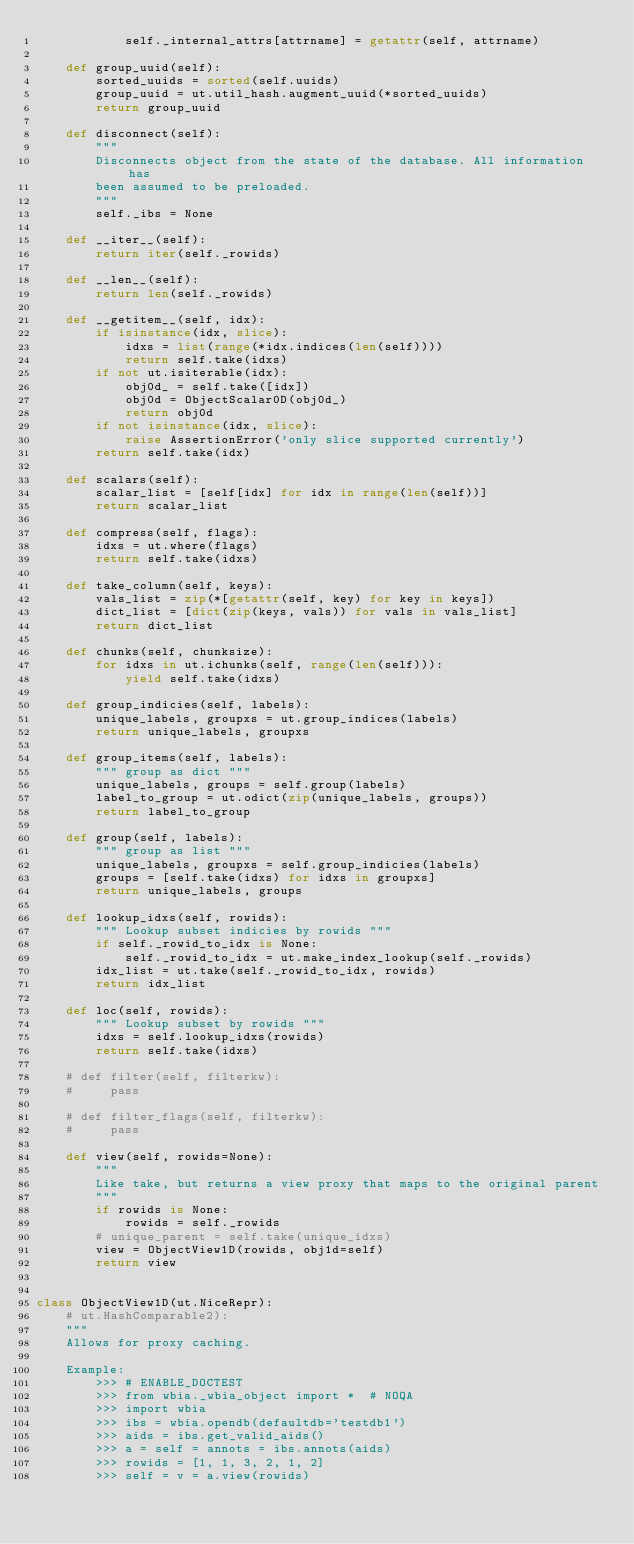Convert code to text. <code><loc_0><loc_0><loc_500><loc_500><_Python_>            self._internal_attrs[attrname] = getattr(self, attrname)

    def group_uuid(self):
        sorted_uuids = sorted(self.uuids)
        group_uuid = ut.util_hash.augment_uuid(*sorted_uuids)
        return group_uuid

    def disconnect(self):
        """
        Disconnects object from the state of the database. All information has
        been assumed to be preloaded.
        """
        self._ibs = None

    def __iter__(self):
        return iter(self._rowids)

    def __len__(self):
        return len(self._rowids)

    def __getitem__(self, idx):
        if isinstance(idx, slice):
            idxs = list(range(*idx.indices(len(self))))
            return self.take(idxs)
        if not ut.isiterable(idx):
            obj0d_ = self.take([idx])
            obj0d = ObjectScalar0D(obj0d_)
            return obj0d
        if not isinstance(idx, slice):
            raise AssertionError('only slice supported currently')
        return self.take(idx)

    def scalars(self):
        scalar_list = [self[idx] for idx in range(len(self))]
        return scalar_list

    def compress(self, flags):
        idxs = ut.where(flags)
        return self.take(idxs)

    def take_column(self, keys):
        vals_list = zip(*[getattr(self, key) for key in keys])
        dict_list = [dict(zip(keys, vals)) for vals in vals_list]
        return dict_list

    def chunks(self, chunksize):
        for idxs in ut.ichunks(self, range(len(self))):
            yield self.take(idxs)

    def group_indicies(self, labels):
        unique_labels, groupxs = ut.group_indices(labels)
        return unique_labels, groupxs

    def group_items(self, labels):
        """ group as dict """
        unique_labels, groups = self.group(labels)
        label_to_group = ut.odict(zip(unique_labels, groups))
        return label_to_group

    def group(self, labels):
        """ group as list """
        unique_labels, groupxs = self.group_indicies(labels)
        groups = [self.take(idxs) for idxs in groupxs]
        return unique_labels, groups

    def lookup_idxs(self, rowids):
        """ Lookup subset indicies by rowids """
        if self._rowid_to_idx is None:
            self._rowid_to_idx = ut.make_index_lookup(self._rowids)
        idx_list = ut.take(self._rowid_to_idx, rowids)
        return idx_list

    def loc(self, rowids):
        """ Lookup subset by rowids """
        idxs = self.lookup_idxs(rowids)
        return self.take(idxs)

    # def filter(self, filterkw):
    #     pass

    # def filter_flags(self, filterkw):
    #     pass

    def view(self, rowids=None):
        """
        Like take, but returns a view proxy that maps to the original parent
        """
        if rowids is None:
            rowids = self._rowids
        # unique_parent = self.take(unique_idxs)
        view = ObjectView1D(rowids, obj1d=self)
        return view


class ObjectView1D(ut.NiceRepr):
    # ut.HashComparable2):
    """
    Allows for proxy caching.

    Example:
        >>> # ENABLE_DOCTEST
        >>> from wbia._wbia_object import *  # NOQA
        >>> import wbia
        >>> ibs = wbia.opendb(defaultdb='testdb1')
        >>> aids = ibs.get_valid_aids()
        >>> a = self = annots = ibs.annots(aids)
        >>> rowids = [1, 1, 3, 2, 1, 2]
        >>> self = v = a.view(rowids)</code> 